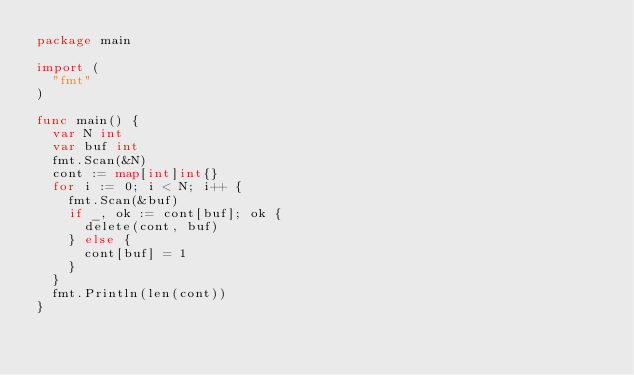Convert code to text. <code><loc_0><loc_0><loc_500><loc_500><_Go_>package main

import (
	"fmt"
)

func main() {
	var N int
	var buf int
	fmt.Scan(&N)
	cont := map[int]int{}
	for i := 0; i < N; i++ {
		fmt.Scan(&buf)
		if _, ok := cont[buf]; ok {
			delete(cont, buf)
		} else {
			cont[buf] = 1
		}
	}
	fmt.Println(len(cont))
}
</code> 